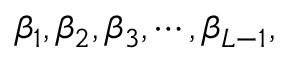Convert formula to latex. <formula><loc_0><loc_0><loc_500><loc_500>\beta _ { 1 } , \beta _ { 2 } , \beta _ { 3 } , \cdots , \beta _ { L - 1 } ,</formula> 